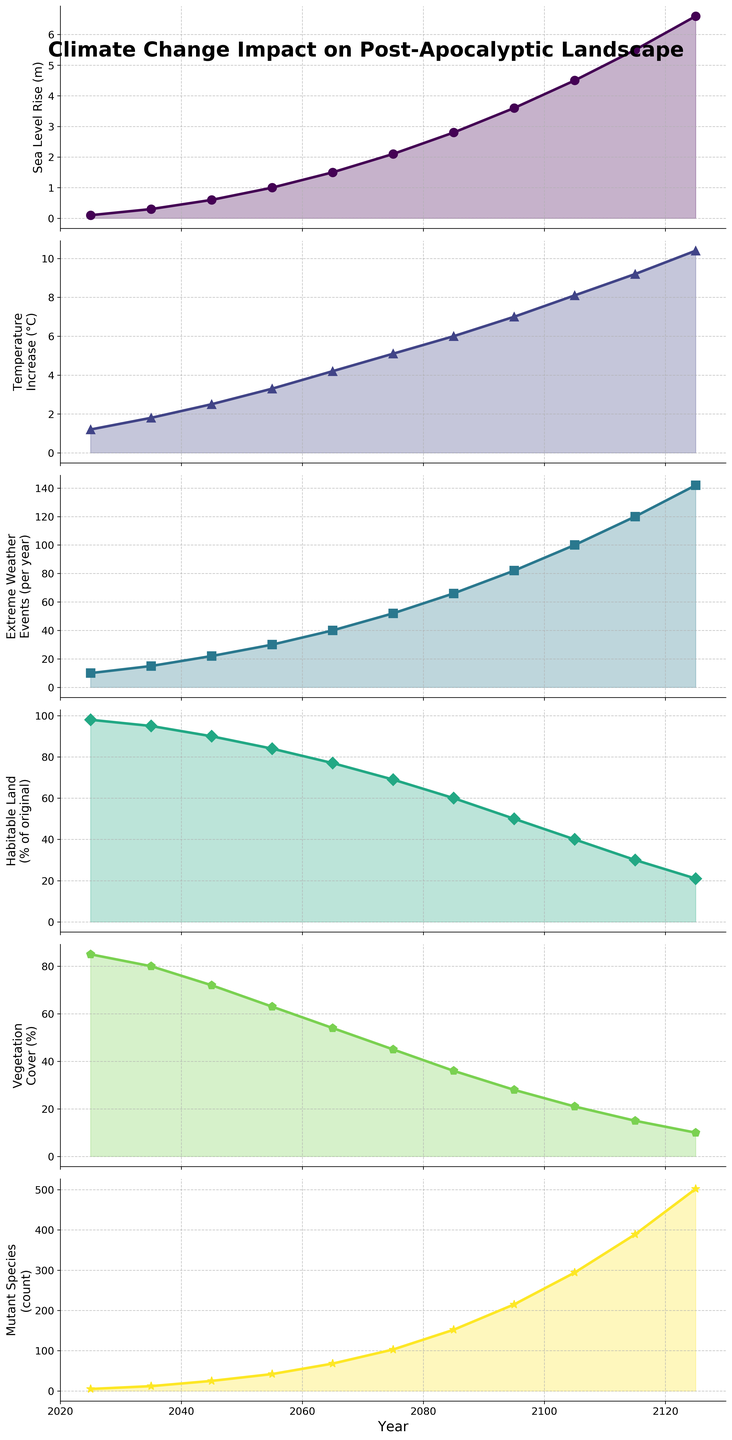What year does the sea level rise surpass 4 meters? The plot for "Sea Level Rise (m)" shows the level surpasses 4 meters at the data point corresponding to 2105, making it the first year the level goes beyond this threshold.
Answer: 2105 In which year does habitable land percentage drop below 50%? The plot for "Habitable Land (% of original)" shows that the percentage drops below 50% for the first time in the year 2095, denoted by a y-axis value crossing below the 50 line.
Answer: 2095 Which metric shows the steepest increase rate from 2025 to 2125? By visually comparing the slopes of all six plots, "Mutant Species (count)" has the steepest slope, indicating the fastest increase rate over the period.
Answer: Mutant Species (count) What is the difference in vegetation cover percentage between the years 2065 and 2115? The "Vegetation Cover (%)" plot has values of 54% in 2065 and 15% in 2115. The difference is calculated as 54% - 15%.
Answer: 39% How does the number of extreme weather events per year change between 2045 and 2085? The plot for "Extreme Weather Events (per year)" shows an increase from 22 events in 2045 to 66 events in 2085.
Answer: 44 Compare the percentage decrease in habitable land from 2055 to 2115. The values for "Habitable Land (% of original)" are 84% in 2055 and 30% in 2115. The percentage decrease is calculated as [(84 - 30) / 84] * 100.
Answer: 64.29% When does the temperature rise reach over 7°C, and how much does it continue to increase by 2125? The "Temperature Increase (°C)" plot exceeds 7°C in 2095. From 2095 to 2125, it increases from 7°C to 10.4°C, an increase of 3.4°C.
Answer: Exceeds in 2095, increases by 3.4°C By how much does sea level rise from 2045 to 2075? The "Sea Level Rise (m)" plot indicates values are 0.6 meters in 2045 and 2.1 meters in 2075. The rise is 2.1 - 0.6 meters.
Answer: 1.5 meters What is the visual trend in vegetation cover percentage over the century? The plot for "Vegetation Cover (%)" shows a consistent decline from 85% in 2025 to 10% in 2125, indicating a continuous decreasing trend throughout the century.
Answer: Continuous decrease Which year sees the peak number of extreme weather events? The "Extreme Weather Events (per year)" plot peaks at 142 events in 2125, the highest value shown.
Answer: 2125 